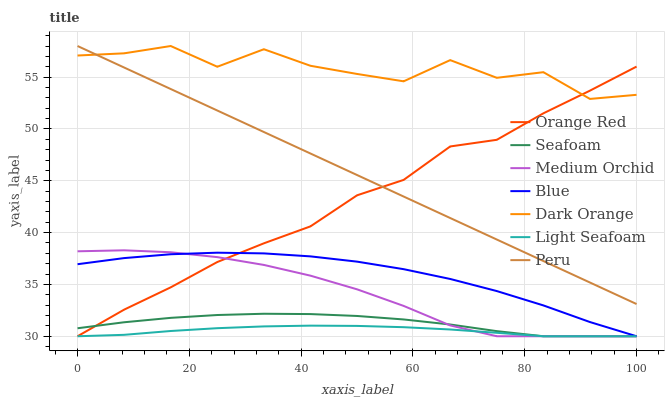Does Light Seafoam have the minimum area under the curve?
Answer yes or no. Yes. Does Dark Orange have the maximum area under the curve?
Answer yes or no. Yes. Does Medium Orchid have the minimum area under the curve?
Answer yes or no. No. Does Medium Orchid have the maximum area under the curve?
Answer yes or no. No. Is Peru the smoothest?
Answer yes or no. Yes. Is Dark Orange the roughest?
Answer yes or no. Yes. Is Medium Orchid the smoothest?
Answer yes or no. No. Is Medium Orchid the roughest?
Answer yes or no. No. Does Blue have the lowest value?
Answer yes or no. Yes. Does Dark Orange have the lowest value?
Answer yes or no. No. Does Peru have the highest value?
Answer yes or no. Yes. Does Medium Orchid have the highest value?
Answer yes or no. No. Is Light Seafoam less than Peru?
Answer yes or no. Yes. Is Dark Orange greater than Blue?
Answer yes or no. Yes. Does Light Seafoam intersect Orange Red?
Answer yes or no. Yes. Is Light Seafoam less than Orange Red?
Answer yes or no. No. Is Light Seafoam greater than Orange Red?
Answer yes or no. No. Does Light Seafoam intersect Peru?
Answer yes or no. No. 